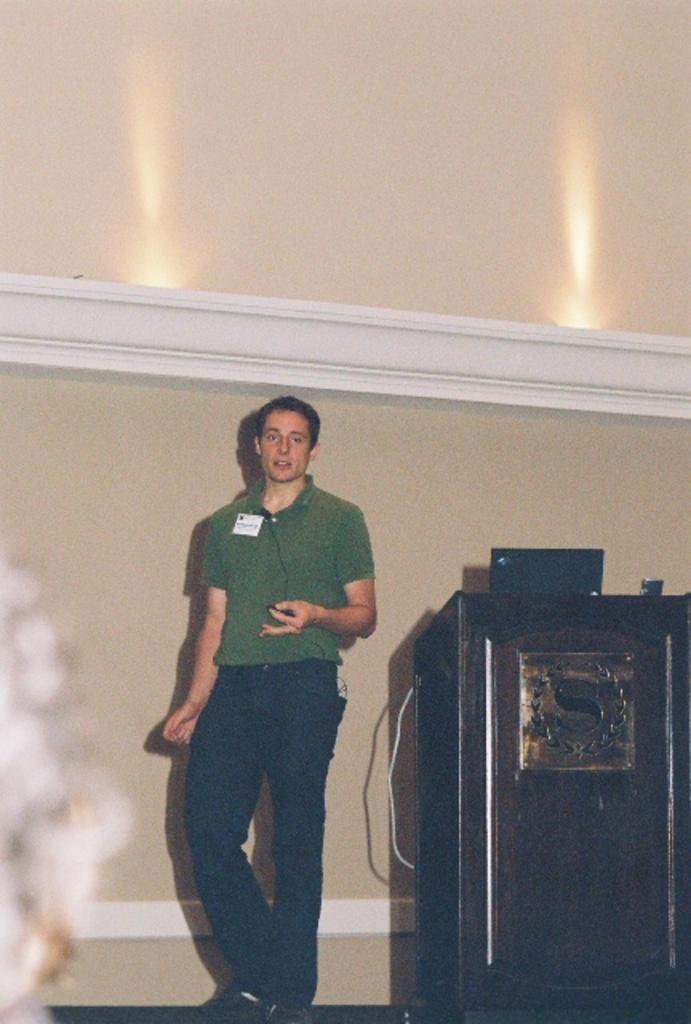Please provide a concise description of this image. Here we can see a man standing on the floor. This is a podium. In the background we can see wall. 